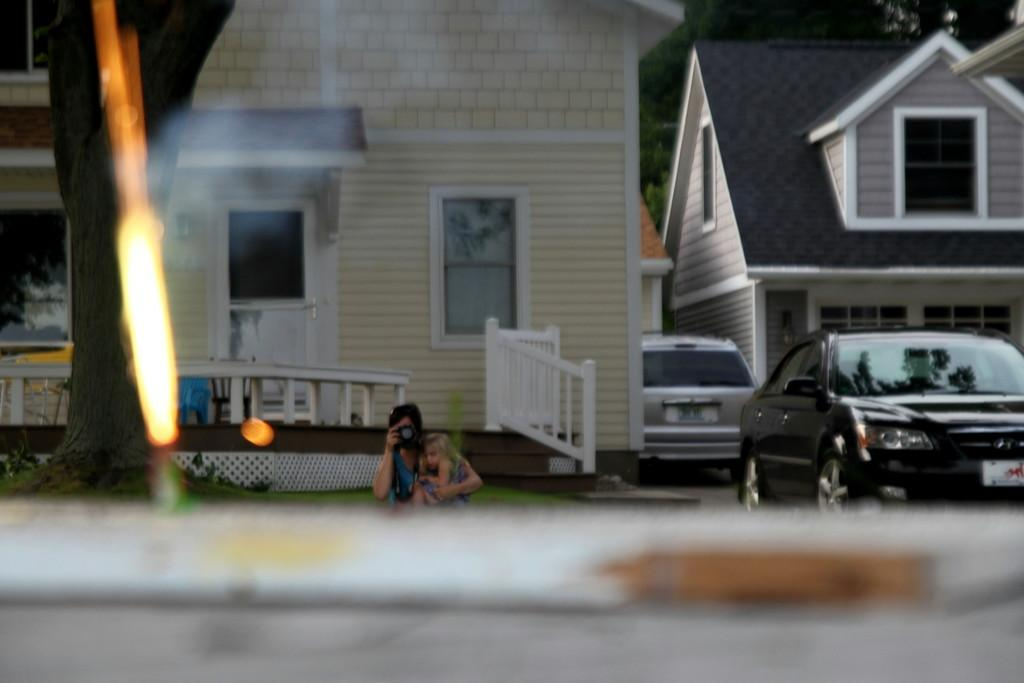What type of structures can be seen in the image? There are buildings in the image. What other elements are present in the image besides buildings? There are trees, two cars, and a person carrying a baby in the image. What is the person doing in the image? The person is clicking a picture. How is the foreground of the image described? The foreground of the image is blurry. What type of wax is being used to create the buildings in the image? There is no wax present in the image; the buildings are real structures. What color of ink is being used to draw the trees in the image? There is no ink present in the image; the trees are real plants. 